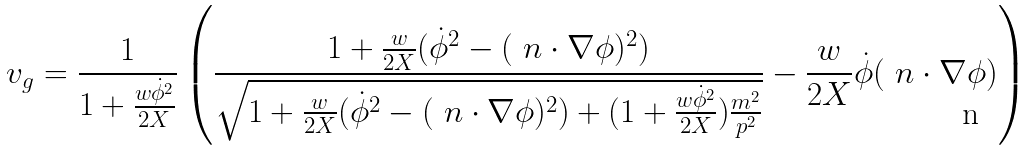<formula> <loc_0><loc_0><loc_500><loc_500>v _ { g } = \frac { 1 } { 1 + \frac { w \dot { \phi } ^ { 2 } } { 2 X } } \left ( \frac { 1 + \frac { w } { 2 X } ( \dot { \phi } ^ { 2 } - ( \ n \cdot \nabla \phi ) ^ { 2 } ) } { \sqrt { 1 + \frac { w } { 2 X } ( \dot { \phi } ^ { 2 } - ( \ n \cdot \nabla \phi ) ^ { 2 } ) + ( 1 + \frac { w \dot { \phi } ^ { 2 } } { 2 X } ) \frac { m ^ { 2 } } { p ^ { 2 } } } } - \frac { w } { 2 X } \dot { \phi } ( \ n \cdot \nabla \phi ) \right )</formula> 